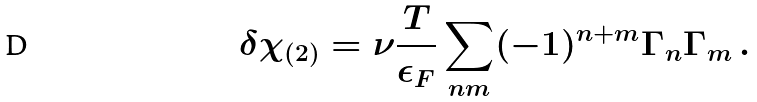<formula> <loc_0><loc_0><loc_500><loc_500>\delta \chi _ { ( 2 ) } = \nu \frac { T } { \epsilon _ { F } } \sum _ { n m } ( - 1 ) ^ { n + m } \Gamma _ { n } \Gamma _ { m } \, .</formula> 